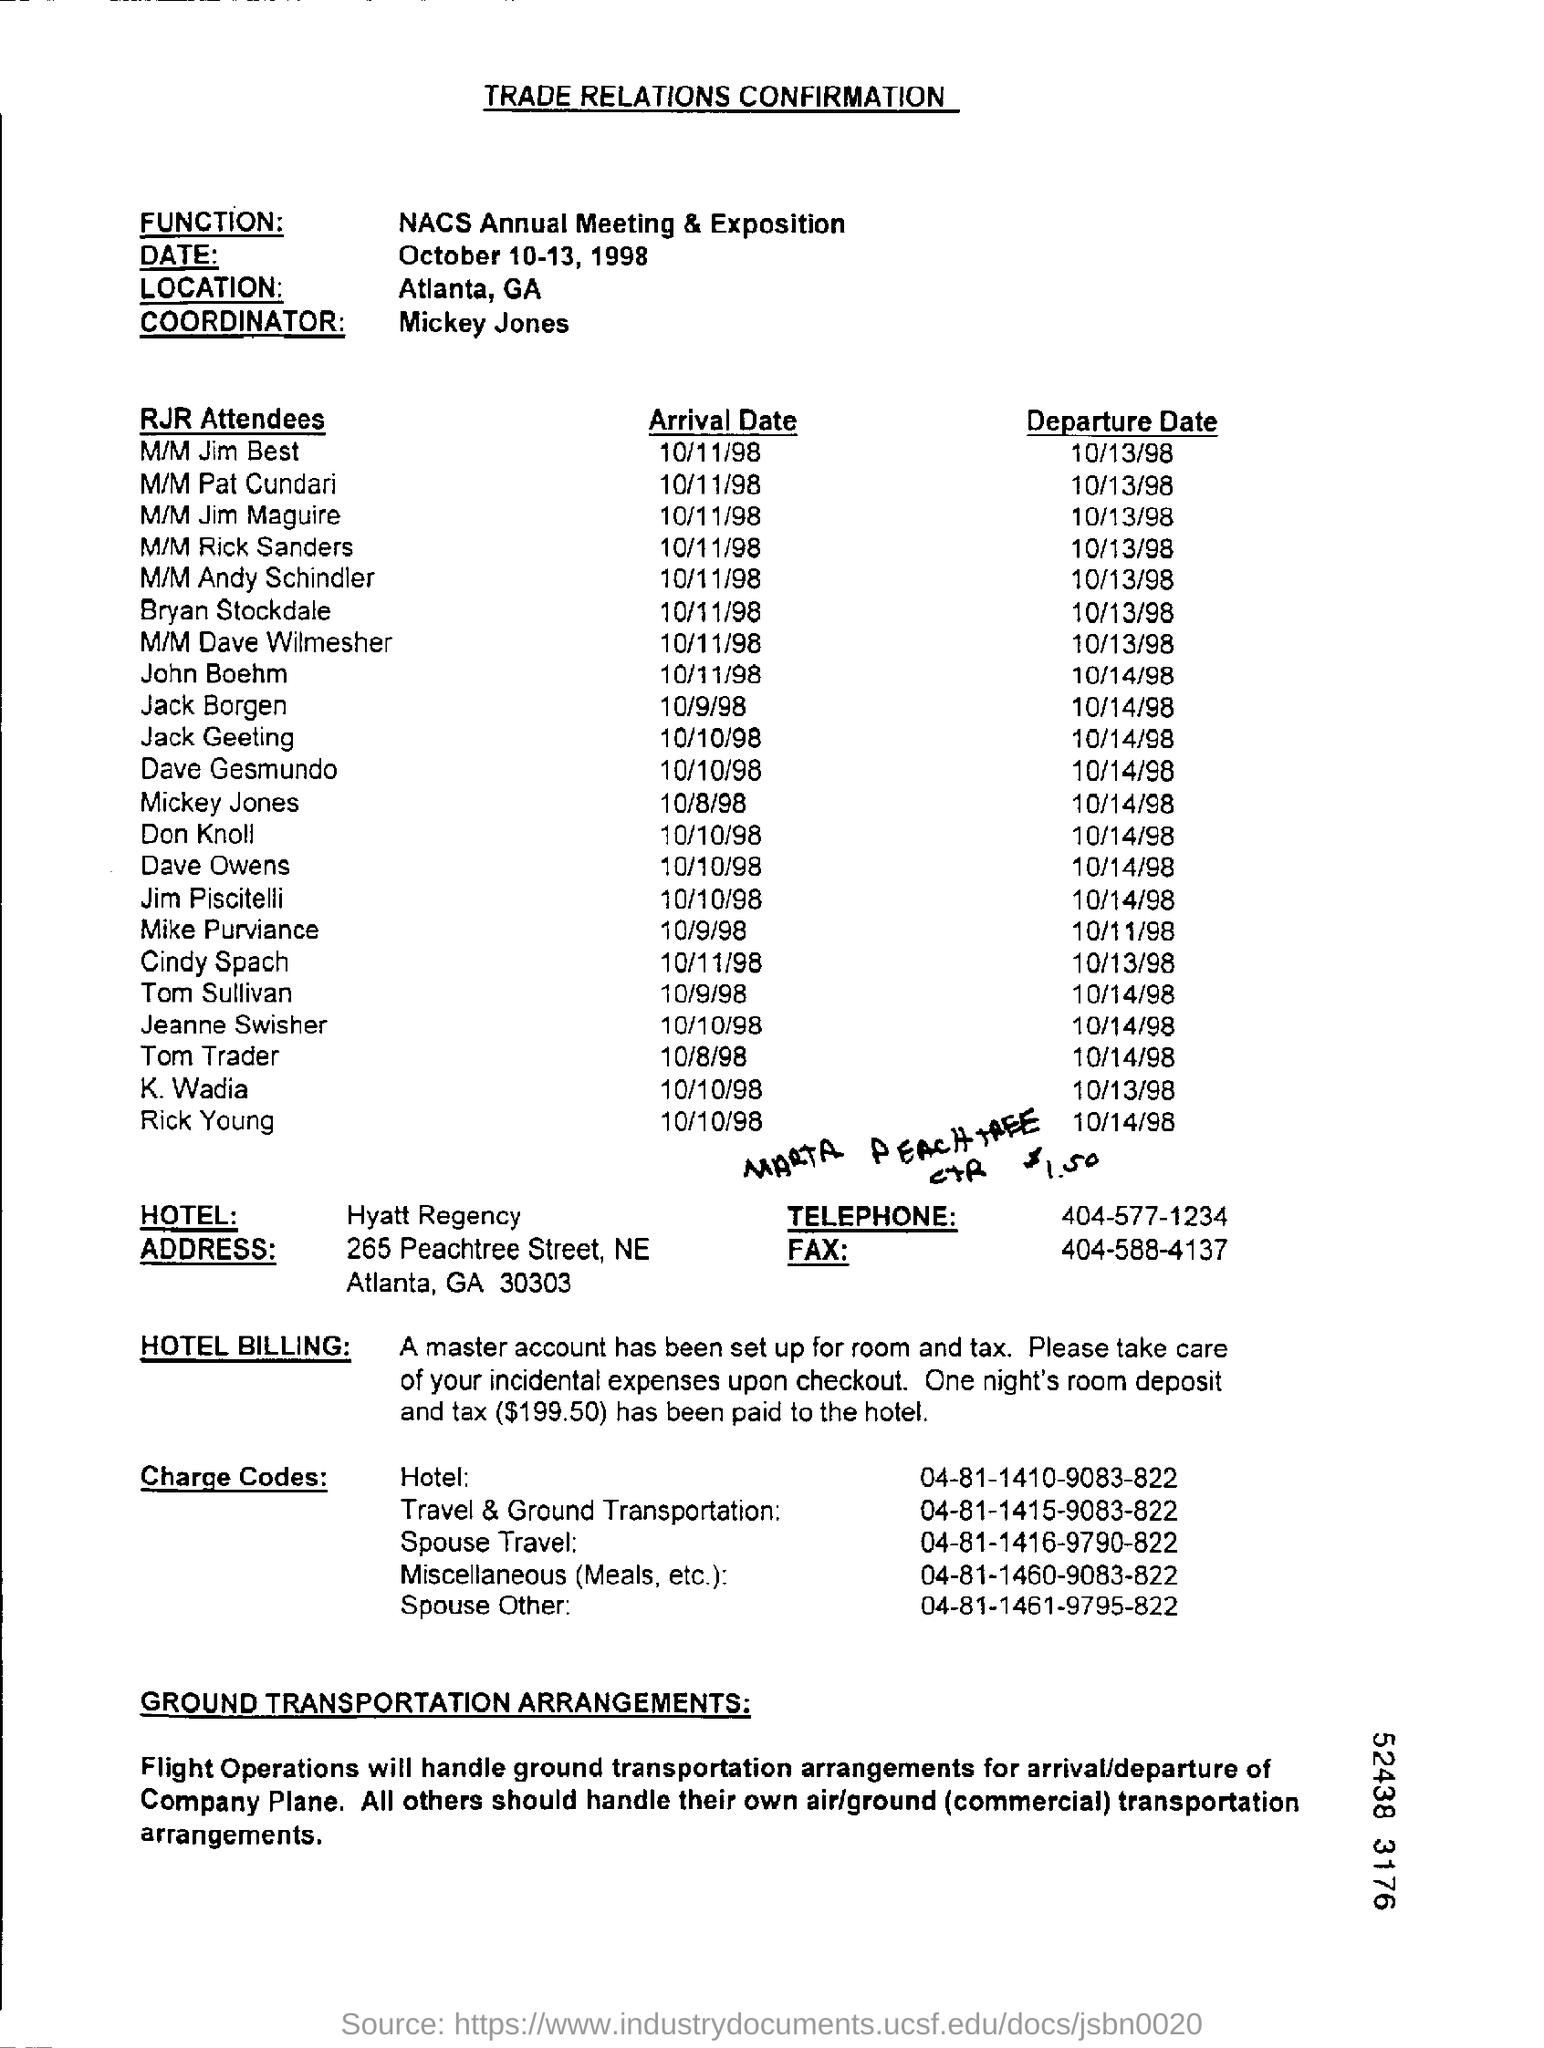Specify some key components in this picture. Atlanta, Georgia is the location. The NACS Annual Meeting & Exposition is a function that serves as a platform for companies to showcase their products and services in the convenience and petroleum industry. The date of October 10-13, 1998, was on Thursday, Friday, and Saturday. The name of the hotel is Hyatt Regency. The name of the coordinator is Mickey Jones. 